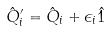<formula> <loc_0><loc_0><loc_500><loc_500>\hat { Q } _ { i } ^ { \prime } = \hat { Q } _ { i } + { \epsilon } _ { i } \hat { 1 }</formula> 